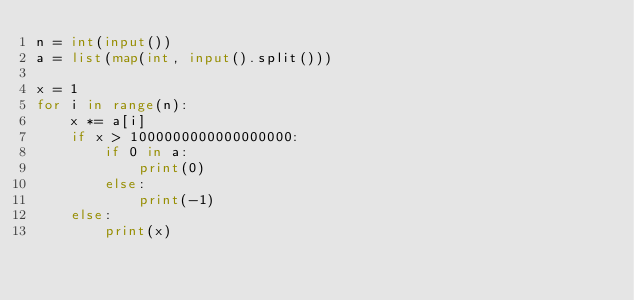<code> <loc_0><loc_0><loc_500><loc_500><_Python_>n = int(input())
a = list(map(int, input().split()))

x = 1
for i in range(n):
    x *= a[i]    
    if x > 1000000000000000000:
        if 0 in a:
            print(0)
        else:
            print(-1)
    else:
        print(x)
</code> 